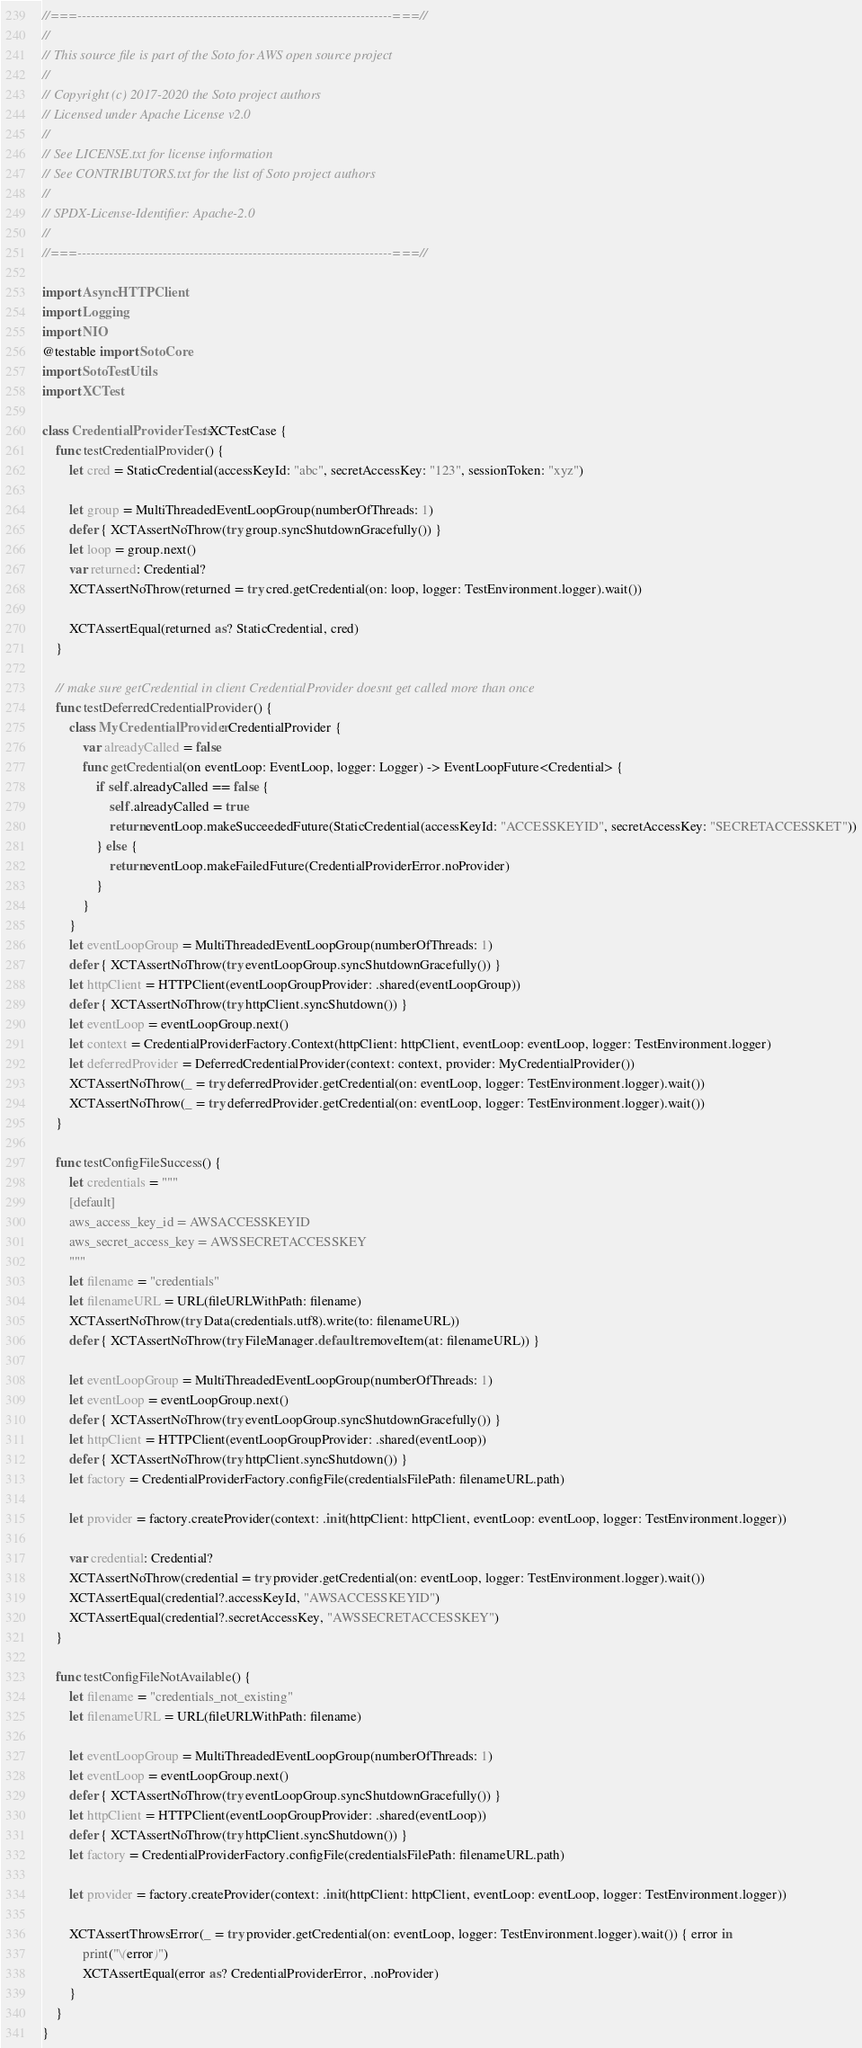Convert code to text. <code><loc_0><loc_0><loc_500><loc_500><_Swift_>//===----------------------------------------------------------------------===//
//
// This source file is part of the Soto for AWS open source project
//
// Copyright (c) 2017-2020 the Soto project authors
// Licensed under Apache License v2.0
//
// See LICENSE.txt for license information
// See CONTRIBUTORS.txt for the list of Soto project authors
//
// SPDX-License-Identifier: Apache-2.0
//
//===----------------------------------------------------------------------===//

import AsyncHTTPClient
import Logging
import NIO
@testable import SotoCore
import SotoTestUtils
import XCTest

class CredentialProviderTests: XCTestCase {
    func testCredentialProvider() {
        let cred = StaticCredential(accessKeyId: "abc", secretAccessKey: "123", sessionToken: "xyz")

        let group = MultiThreadedEventLoopGroup(numberOfThreads: 1)
        defer { XCTAssertNoThrow(try group.syncShutdownGracefully()) }
        let loop = group.next()
        var returned: Credential?
        XCTAssertNoThrow(returned = try cred.getCredential(on: loop, logger: TestEnvironment.logger).wait())

        XCTAssertEqual(returned as? StaticCredential, cred)
    }

    // make sure getCredential in client CredentialProvider doesnt get called more than once
    func testDeferredCredentialProvider() {
        class MyCredentialProvider: CredentialProvider {
            var alreadyCalled = false
            func getCredential(on eventLoop: EventLoop, logger: Logger) -> EventLoopFuture<Credential> {
                if self.alreadyCalled == false {
                    self.alreadyCalled = true
                    return eventLoop.makeSucceededFuture(StaticCredential(accessKeyId: "ACCESSKEYID", secretAccessKey: "SECRETACCESSKET"))
                } else {
                    return eventLoop.makeFailedFuture(CredentialProviderError.noProvider)
                }
            }
        }
        let eventLoopGroup = MultiThreadedEventLoopGroup(numberOfThreads: 1)
        defer { XCTAssertNoThrow(try eventLoopGroup.syncShutdownGracefully()) }
        let httpClient = HTTPClient(eventLoopGroupProvider: .shared(eventLoopGroup))
        defer { XCTAssertNoThrow(try httpClient.syncShutdown()) }
        let eventLoop = eventLoopGroup.next()
        let context = CredentialProviderFactory.Context(httpClient: httpClient, eventLoop: eventLoop, logger: TestEnvironment.logger)
        let deferredProvider = DeferredCredentialProvider(context: context, provider: MyCredentialProvider())
        XCTAssertNoThrow(_ = try deferredProvider.getCredential(on: eventLoop, logger: TestEnvironment.logger).wait())
        XCTAssertNoThrow(_ = try deferredProvider.getCredential(on: eventLoop, logger: TestEnvironment.logger).wait())
    }

    func testConfigFileSuccess() {
        let credentials = """
        [default]
        aws_access_key_id = AWSACCESSKEYID
        aws_secret_access_key = AWSSECRETACCESSKEY
        """
        let filename = "credentials"
        let filenameURL = URL(fileURLWithPath: filename)
        XCTAssertNoThrow(try Data(credentials.utf8).write(to: filenameURL))
        defer { XCTAssertNoThrow(try FileManager.default.removeItem(at: filenameURL)) }

        let eventLoopGroup = MultiThreadedEventLoopGroup(numberOfThreads: 1)
        let eventLoop = eventLoopGroup.next()
        defer { XCTAssertNoThrow(try eventLoopGroup.syncShutdownGracefully()) }
        let httpClient = HTTPClient(eventLoopGroupProvider: .shared(eventLoop))
        defer { XCTAssertNoThrow(try httpClient.syncShutdown()) }
        let factory = CredentialProviderFactory.configFile(credentialsFilePath: filenameURL.path)

        let provider = factory.createProvider(context: .init(httpClient: httpClient, eventLoop: eventLoop, logger: TestEnvironment.logger))

        var credential: Credential?
        XCTAssertNoThrow(credential = try provider.getCredential(on: eventLoop, logger: TestEnvironment.logger).wait())
        XCTAssertEqual(credential?.accessKeyId, "AWSACCESSKEYID")
        XCTAssertEqual(credential?.secretAccessKey, "AWSSECRETACCESSKEY")
    }

    func testConfigFileNotAvailable() {
        let filename = "credentials_not_existing"
        let filenameURL = URL(fileURLWithPath: filename)

        let eventLoopGroup = MultiThreadedEventLoopGroup(numberOfThreads: 1)
        let eventLoop = eventLoopGroup.next()
        defer { XCTAssertNoThrow(try eventLoopGroup.syncShutdownGracefully()) }
        let httpClient = HTTPClient(eventLoopGroupProvider: .shared(eventLoop))
        defer { XCTAssertNoThrow(try httpClient.syncShutdown()) }
        let factory = CredentialProviderFactory.configFile(credentialsFilePath: filenameURL.path)

        let provider = factory.createProvider(context: .init(httpClient: httpClient, eventLoop: eventLoop, logger: TestEnvironment.logger))

        XCTAssertThrowsError(_ = try provider.getCredential(on: eventLoop, logger: TestEnvironment.logger).wait()) { error in
            print("\(error)")
            XCTAssertEqual(error as? CredentialProviderError, .noProvider)
        }
    }
}
</code> 